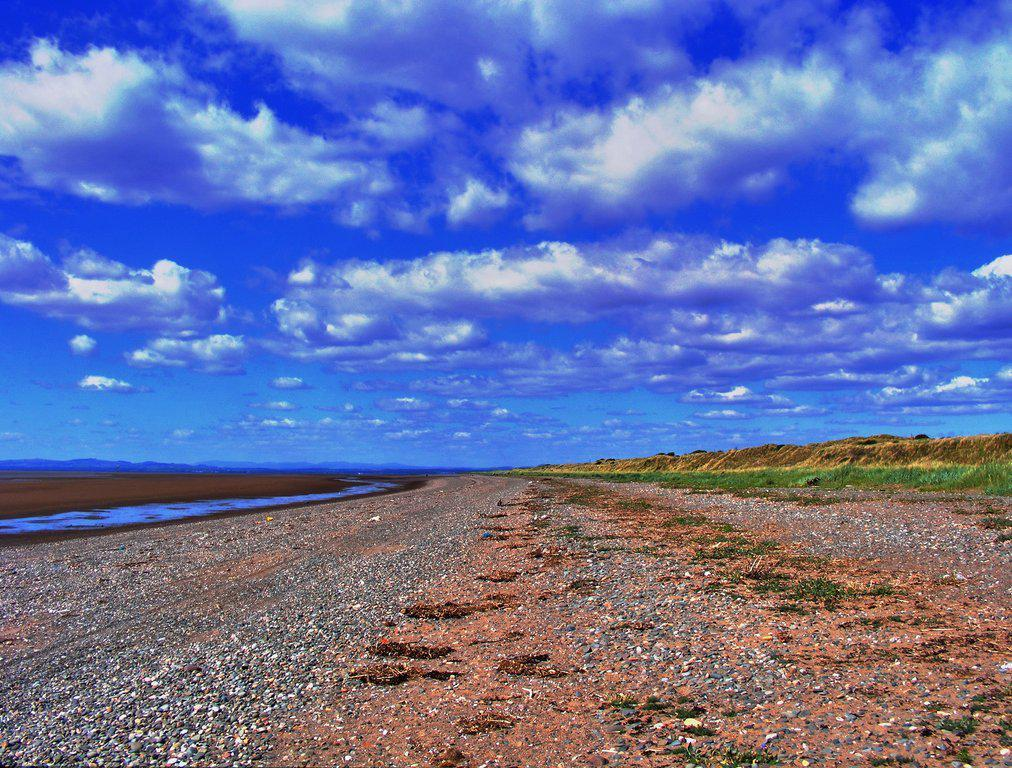What type of terrain is visible on the ground in the image? The ground in the image is covered with sand and stones. What can be seen on the land in the image? There is water on the land in the image. What type of landscape feature is visible in the background of the image? There are small hills in the background of the image. What is the condition of the sky in the image? The sky is cloudy in the image. What type of headwear is the coach wearing in the image? There is no coach or headwear present in the image. 